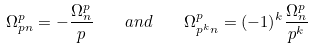<formula> <loc_0><loc_0><loc_500><loc_500>\Omega ^ { p } _ { p n } = - \frac { \Omega ^ { p } _ { n } } { p } \quad a n d \quad \Omega ^ { p } _ { p ^ { k } n } = { ( - 1 ) ^ { k } } \frac { \Omega ^ { p } _ { n } } { p ^ { k } }</formula> 